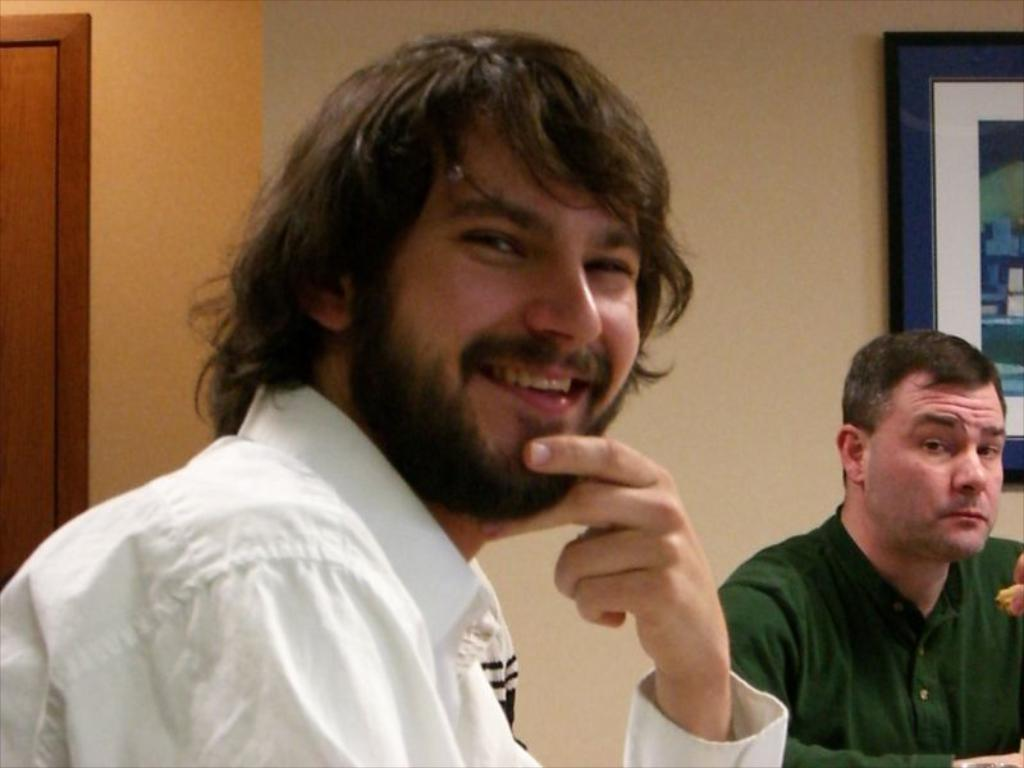How many people are in the image? There are two men in the image. What are the men wearing? Both men are wearing clothes. Can you describe the facial expression of the man on the left side? The man on the left side is smiling. What is the frame attached to in the image? The frame is attached to a wall. Is there a wall visible in the image? Yes, there is a wall visible in the image. What type of authority does the man on the right side have in the image? There is no indication of authority in the image; it only shows two men and a frame attached to a wall. 